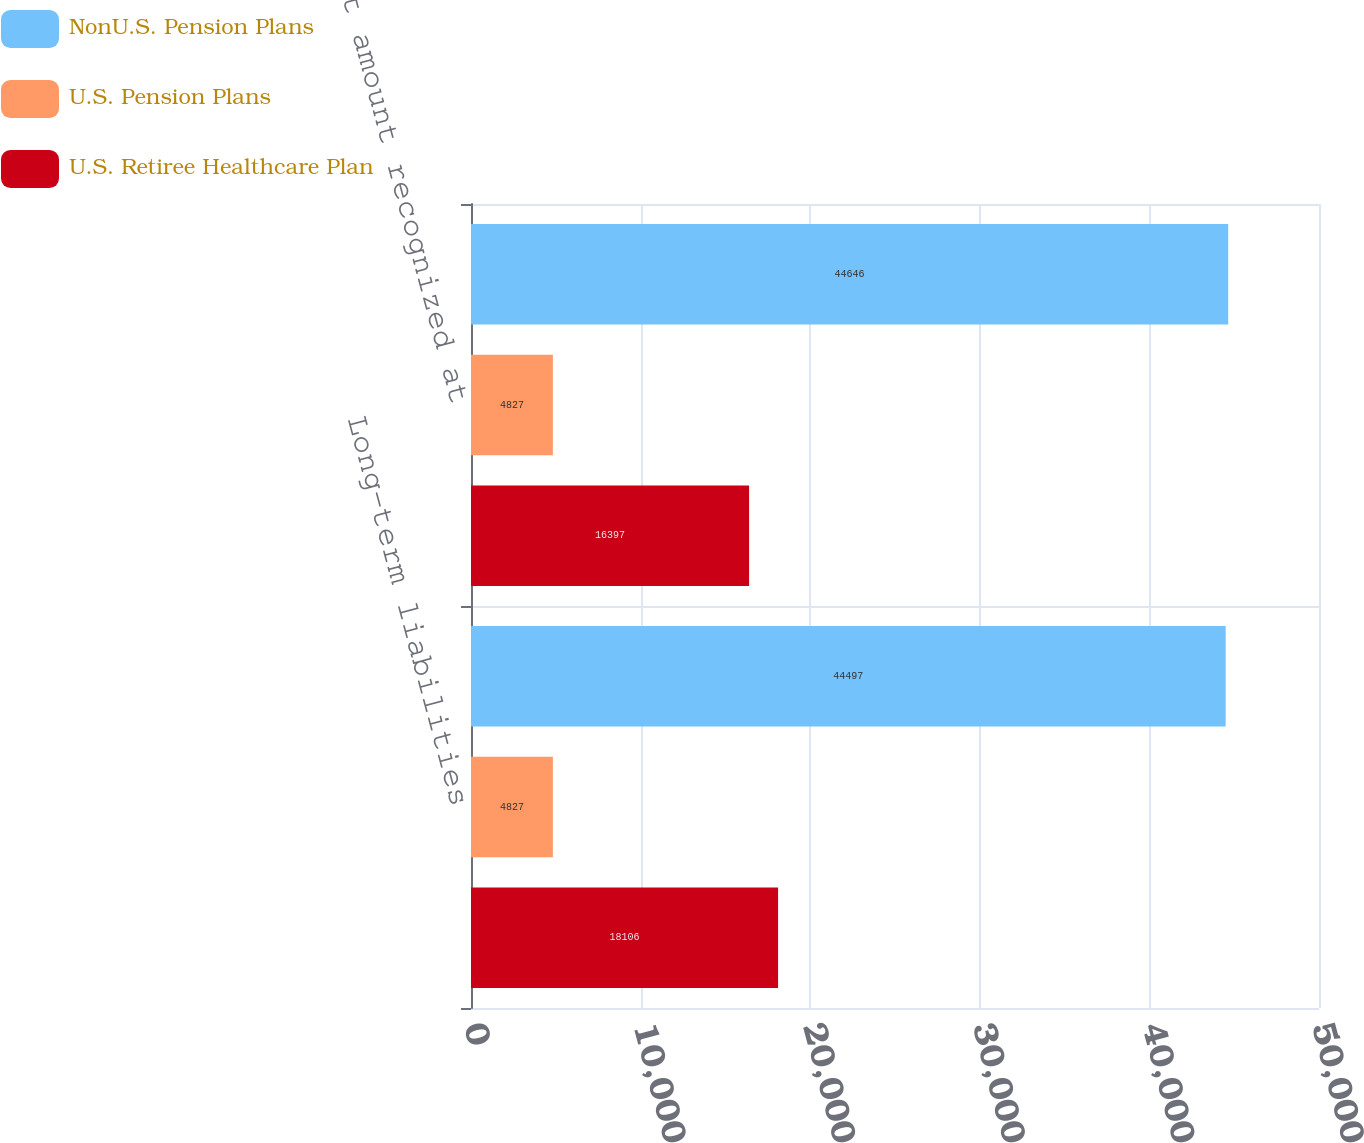Convert chart. <chart><loc_0><loc_0><loc_500><loc_500><stacked_bar_chart><ecel><fcel>Long-term liabilities<fcel>Net amount recognized at<nl><fcel>NonU.S. Pension Plans<fcel>44497<fcel>44646<nl><fcel>U.S. Pension Plans<fcel>4827<fcel>4827<nl><fcel>U.S. Retiree Healthcare Plan<fcel>18106<fcel>16397<nl></chart> 